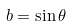<formula> <loc_0><loc_0><loc_500><loc_500>b = \sin \theta</formula> 